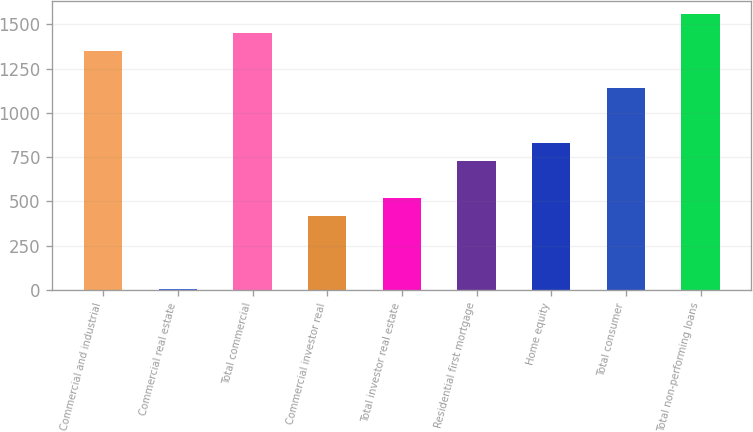Convert chart. <chart><loc_0><loc_0><loc_500><loc_500><bar_chart><fcel>Commercial and industrial<fcel>Commercial real estate<fcel>Total commercial<fcel>Commercial investor real<fcel>Total investor real estate<fcel>Residential first mortgage<fcel>Home equity<fcel>Total consumer<fcel>Total non-performing loans<nl><fcel>1350.1<fcel>2<fcel>1453.8<fcel>416.8<fcel>520.5<fcel>727.9<fcel>831.6<fcel>1142.7<fcel>1557.5<nl></chart> 